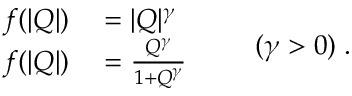<formula> <loc_0><loc_0><loc_500><loc_500>\begin{array} { r l } { f ( | Q | ) } & = | Q | ^ { \gamma } } \\ { f ( | Q | ) } & = \frac { Q ^ { \gamma } } { 1 + Q ^ { \gamma } } } \end{array} \quad ( \gamma > 0 ) \, .</formula> 